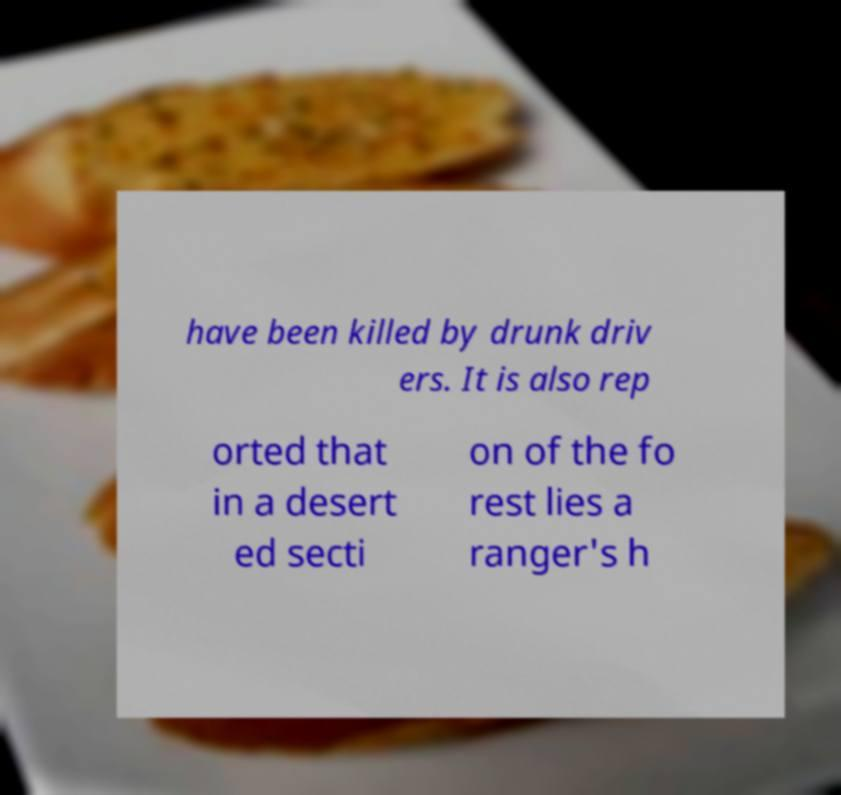Please identify and transcribe the text found in this image. have been killed by drunk driv ers. It is also rep orted that in a desert ed secti on of the fo rest lies a ranger's h 